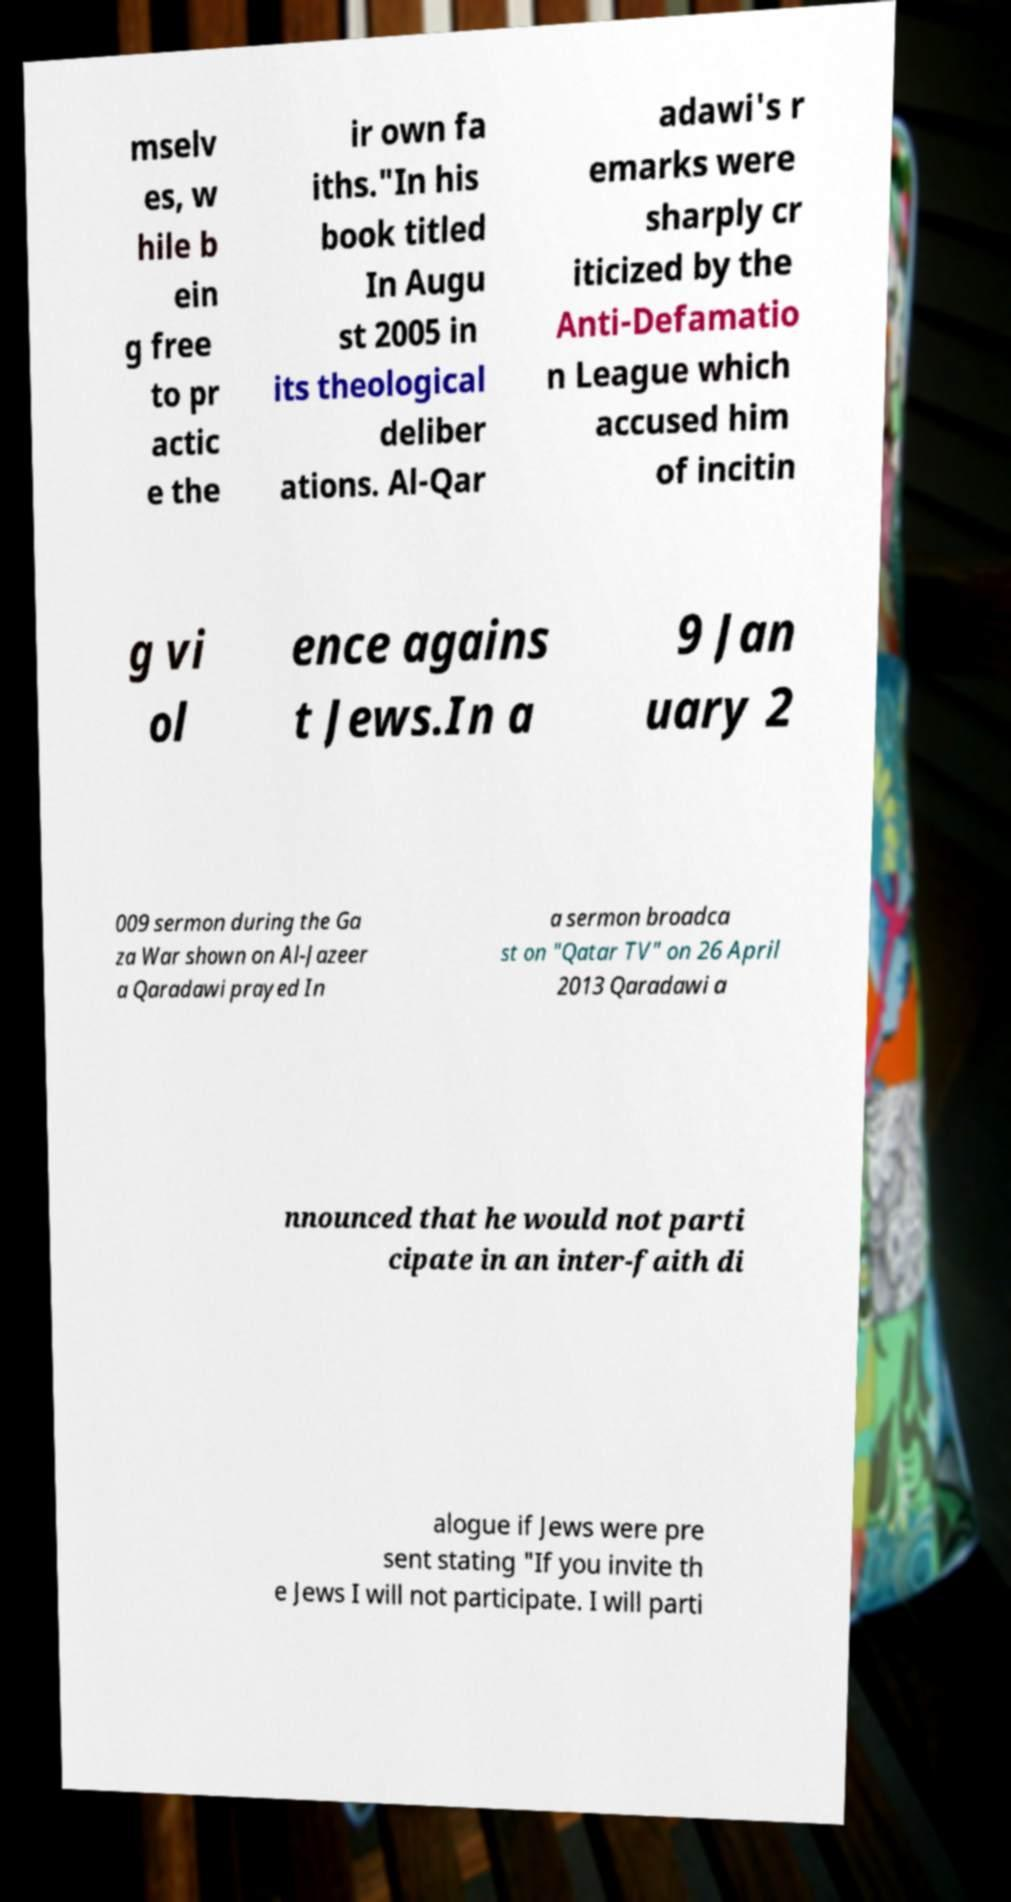Please read and relay the text visible in this image. What does it say? mselv es, w hile b ein g free to pr actic e the ir own fa iths."In his book titled In Augu st 2005 in its theological deliber ations. Al-Qar adawi's r emarks were sharply cr iticized by the Anti-Defamatio n League which accused him of incitin g vi ol ence agains t Jews.In a 9 Jan uary 2 009 sermon during the Ga za War shown on Al-Jazeer a Qaradawi prayed In a sermon broadca st on "Qatar TV" on 26 April 2013 Qaradawi a nnounced that he would not parti cipate in an inter-faith di alogue if Jews were pre sent stating "If you invite th e Jews I will not participate. I will parti 